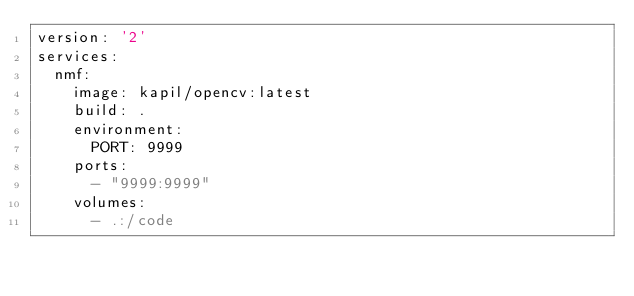Convert code to text. <code><loc_0><loc_0><loc_500><loc_500><_YAML_>version: '2'
services:
  nmf:
    image: kapil/opencv:latest
    build: .
    environment:
      PORT: 9999
    ports:
      - "9999:9999"
    volumes:
      - .:/code
</code> 